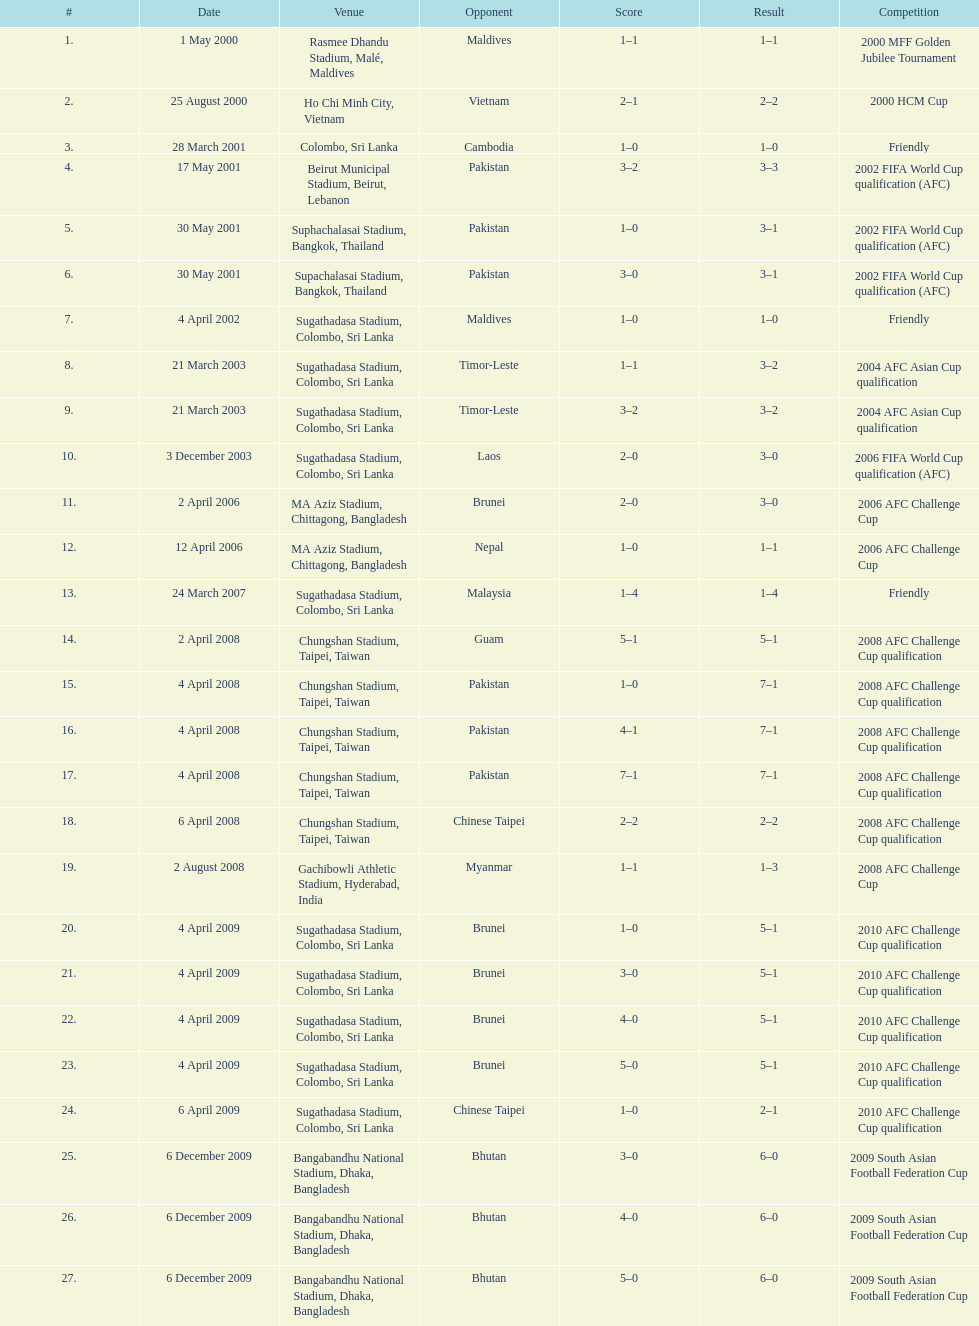Which team did this player face before pakistan on april 4, 2008? Guam. 